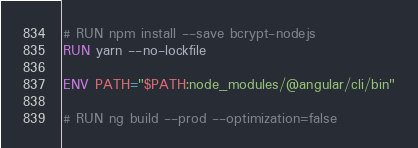<code> <loc_0><loc_0><loc_500><loc_500><_Dockerfile_># RUN npm install --save bcrypt-nodejs
RUN yarn --no-lockfile

ENV PATH="$PATH:node_modules/@angular/cli/bin"

# RUN ng build --prod --optimization=false
</code> 